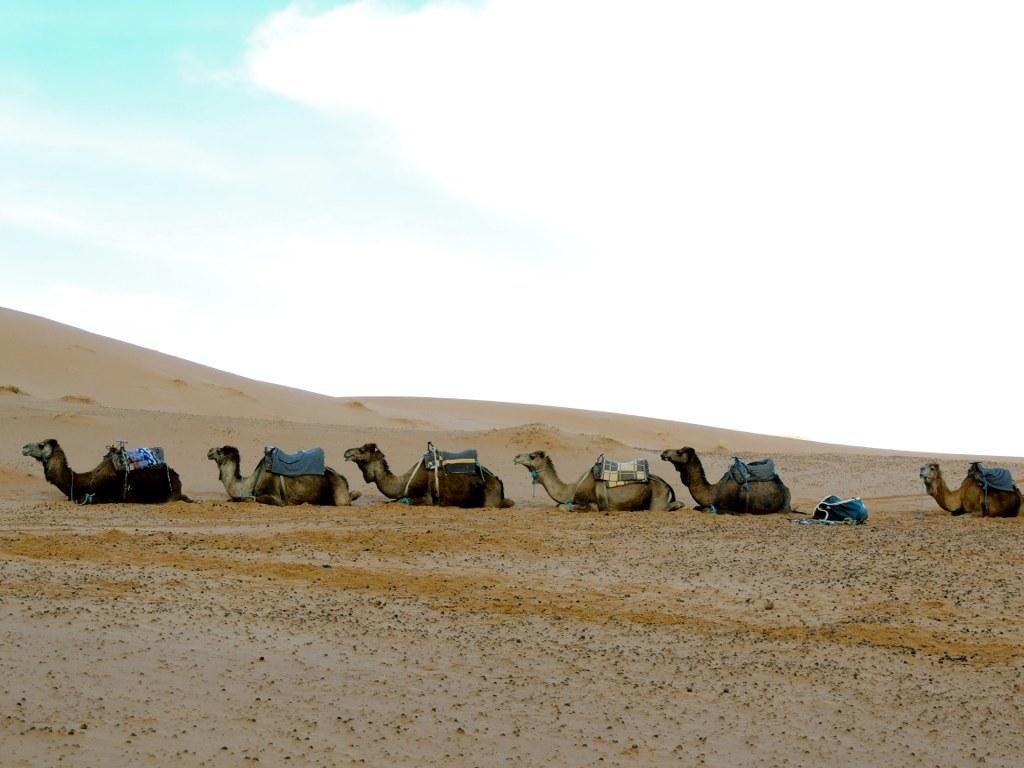What can be seen in the background of the image? The sky is visible in the background of the image. What animals are present in the image? There are camels in the image. Can you describe the unspecified object in the image? Unfortunately, the provided facts do not give enough information to describe the unspecified object in the image. What type of pencil is being used to draw the camels in the image? There is no pencil present in the image, as it features camels and a sky background. 